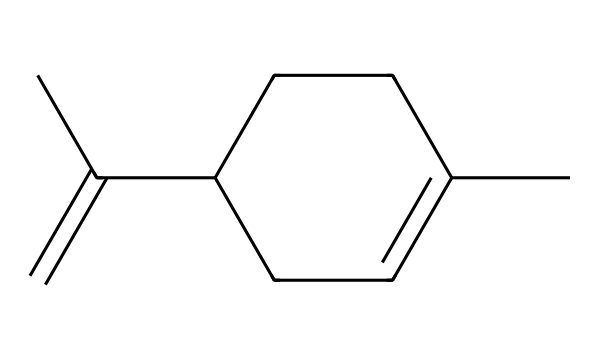What is the molecular formula of limonene? The molecular formula can be determined by counting the carbon (C) and hydrogen (H) atoms in the structure. There are 10 carbon atoms and 16 hydrogen atoms in the structure, leading to the molecular formula C10H16.
Answer: C10H16 How many chiral centers are present in limonene? To identify chiral centers, one must look for carbon atoms that are bonded to four different substituents. In limonene's structure, there is one carbon atom that meets this criterion, indicating there is one chiral center.
Answer: 1 What is the shape of limonene's main carbon chain? The main carbon chain in limonene is a cycloalkene due to the presence of the cyclic structure and the double bond. The circular shape can be confirmed by observing the arrangement of the carbon atoms as they form a ring.
Answer: cycloalkene Can limonene exhibit optical isomerism? This compound has a chiral center, which means it can exist in two non-superimposable mirror image forms, thus allowing for optical isomerism. The presence of a chiral center is essential for a compound to exhibit this phenomenon.
Answer: yes What type of compound is limonene? Limonene is classified as a monoterpene, which is a category of terpenes consisting of two isoprene units. This classification can be inferred from the structure showing a C10H16 composition, fitting the monoterpene profile.
Answer: monoterpene 